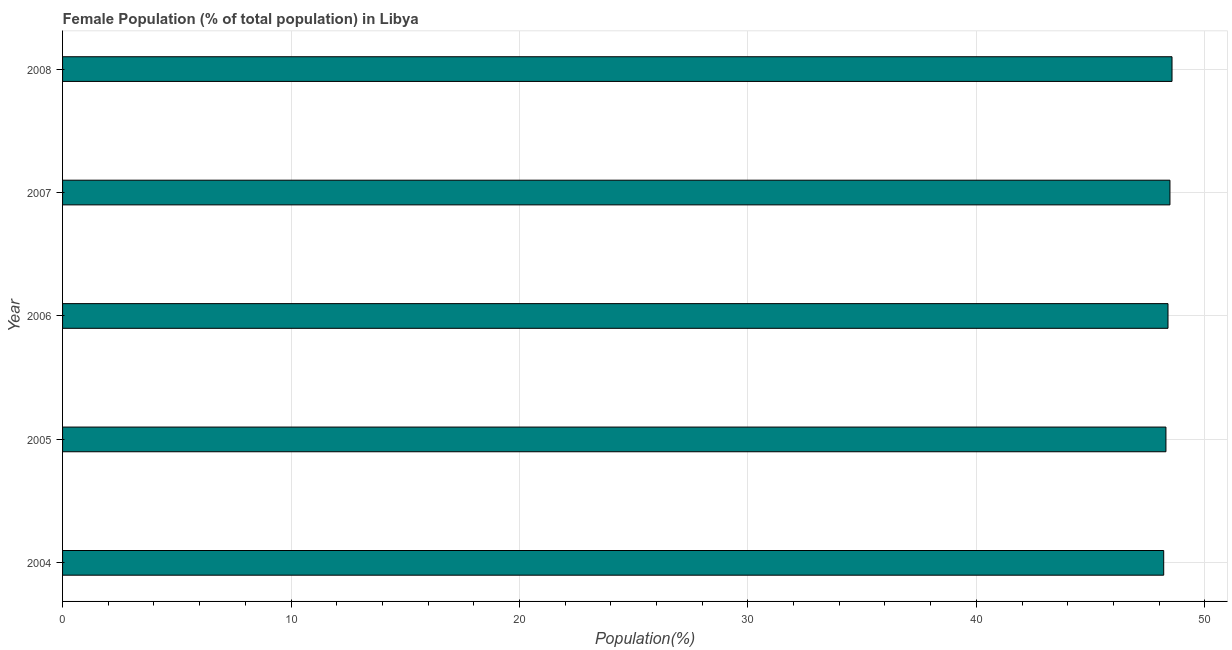Does the graph contain grids?
Give a very brief answer. Yes. What is the title of the graph?
Provide a short and direct response. Female Population (% of total population) in Libya. What is the label or title of the X-axis?
Offer a terse response. Population(%). What is the female population in 2008?
Offer a very short reply. 48.57. Across all years, what is the maximum female population?
Offer a very short reply. 48.57. Across all years, what is the minimum female population?
Keep it short and to the point. 48.2. In which year was the female population minimum?
Give a very brief answer. 2004. What is the sum of the female population?
Give a very brief answer. 241.94. What is the difference between the female population in 2005 and 2007?
Give a very brief answer. -0.18. What is the average female population per year?
Keep it short and to the point. 48.39. What is the median female population?
Offer a terse response. 48.39. What is the ratio of the female population in 2004 to that in 2005?
Your answer should be very brief. 1. Is the female population in 2005 less than that in 2006?
Provide a succinct answer. Yes. What is the difference between the highest and the second highest female population?
Your response must be concise. 0.09. What is the difference between the highest and the lowest female population?
Your answer should be compact. 0.36. How many bars are there?
Your answer should be compact. 5. Are all the bars in the graph horizontal?
Your answer should be very brief. Yes. How many years are there in the graph?
Offer a terse response. 5. What is the difference between two consecutive major ticks on the X-axis?
Keep it short and to the point. 10. Are the values on the major ticks of X-axis written in scientific E-notation?
Keep it short and to the point. No. What is the Population(%) of 2004?
Your answer should be very brief. 48.2. What is the Population(%) in 2005?
Offer a terse response. 48.3. What is the Population(%) of 2006?
Provide a succinct answer. 48.39. What is the Population(%) of 2007?
Your answer should be very brief. 48.48. What is the Population(%) of 2008?
Keep it short and to the point. 48.57. What is the difference between the Population(%) in 2004 and 2005?
Your answer should be compact. -0.1. What is the difference between the Population(%) in 2004 and 2006?
Give a very brief answer. -0.19. What is the difference between the Population(%) in 2004 and 2007?
Your response must be concise. -0.27. What is the difference between the Population(%) in 2004 and 2008?
Your answer should be compact. -0.36. What is the difference between the Population(%) in 2005 and 2006?
Give a very brief answer. -0.09. What is the difference between the Population(%) in 2005 and 2007?
Your answer should be compact. -0.18. What is the difference between the Population(%) in 2005 and 2008?
Offer a very short reply. -0.27. What is the difference between the Population(%) in 2006 and 2007?
Provide a succinct answer. -0.09. What is the difference between the Population(%) in 2006 and 2008?
Your answer should be compact. -0.18. What is the difference between the Population(%) in 2007 and 2008?
Provide a short and direct response. -0.09. What is the ratio of the Population(%) in 2004 to that in 2006?
Provide a succinct answer. 1. What is the ratio of the Population(%) in 2004 to that in 2008?
Make the answer very short. 0.99. What is the ratio of the Population(%) in 2005 to that in 2007?
Keep it short and to the point. 1. What is the ratio of the Population(%) in 2006 to that in 2008?
Make the answer very short. 1. 